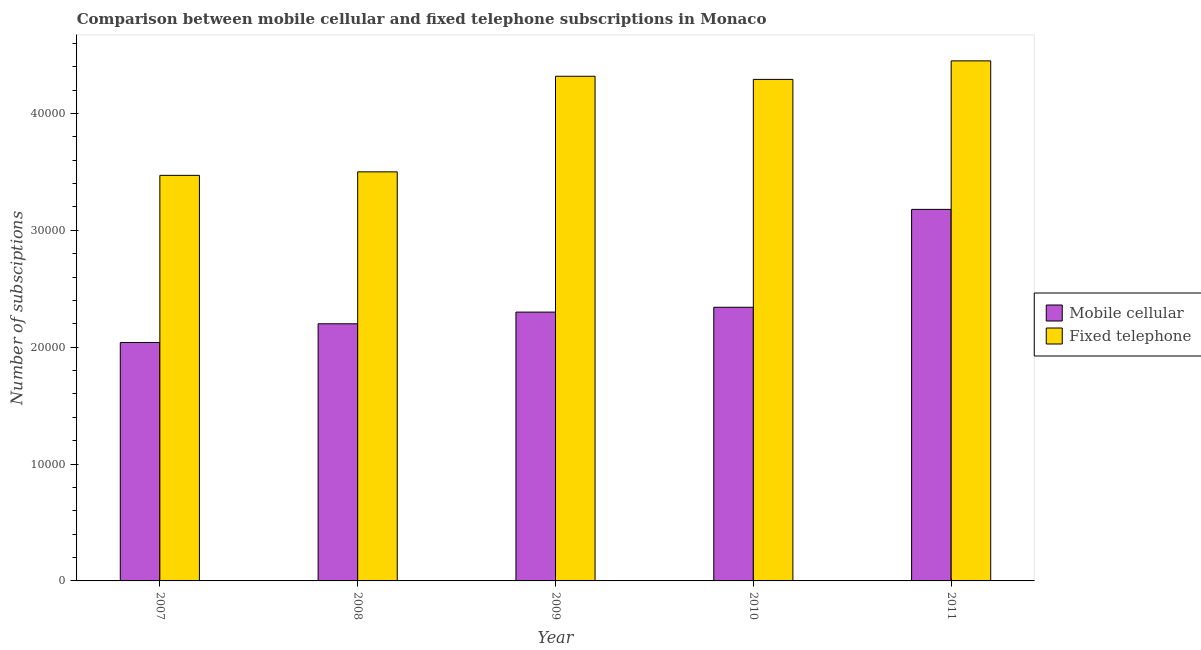How many groups of bars are there?
Provide a succinct answer. 5. Are the number of bars per tick equal to the number of legend labels?
Make the answer very short. Yes. How many bars are there on the 1st tick from the right?
Offer a very short reply. 2. What is the label of the 3rd group of bars from the left?
Offer a terse response. 2009. What is the number of mobile cellular subscriptions in 2011?
Your answer should be very brief. 3.18e+04. Across all years, what is the maximum number of mobile cellular subscriptions?
Give a very brief answer. 3.18e+04. Across all years, what is the minimum number of fixed telephone subscriptions?
Ensure brevity in your answer.  3.47e+04. In which year was the number of mobile cellular subscriptions maximum?
Offer a very short reply. 2011. In which year was the number of fixed telephone subscriptions minimum?
Keep it short and to the point. 2007. What is the total number of fixed telephone subscriptions in the graph?
Provide a short and direct response. 2.00e+05. What is the difference between the number of fixed telephone subscriptions in 2008 and that in 2011?
Your response must be concise. -9495. What is the difference between the number of fixed telephone subscriptions in 2011 and the number of mobile cellular subscriptions in 2010?
Your answer should be compact. 1585. What is the average number of mobile cellular subscriptions per year?
Your answer should be very brief. 2.41e+04. What is the ratio of the number of mobile cellular subscriptions in 2008 to that in 2011?
Your response must be concise. 0.69. Is the number of fixed telephone subscriptions in 2008 less than that in 2010?
Offer a very short reply. Yes. Is the difference between the number of mobile cellular subscriptions in 2008 and 2011 greater than the difference between the number of fixed telephone subscriptions in 2008 and 2011?
Your answer should be very brief. No. What is the difference between the highest and the second highest number of fixed telephone subscriptions?
Ensure brevity in your answer.  1316. What is the difference between the highest and the lowest number of fixed telephone subscriptions?
Your response must be concise. 9795. In how many years, is the number of fixed telephone subscriptions greater than the average number of fixed telephone subscriptions taken over all years?
Your answer should be compact. 3. Is the sum of the number of fixed telephone subscriptions in 2007 and 2008 greater than the maximum number of mobile cellular subscriptions across all years?
Provide a short and direct response. Yes. What does the 1st bar from the left in 2007 represents?
Your answer should be very brief. Mobile cellular. What does the 2nd bar from the right in 2009 represents?
Offer a very short reply. Mobile cellular. Are all the bars in the graph horizontal?
Give a very brief answer. No. How many years are there in the graph?
Your answer should be very brief. 5. Are the values on the major ticks of Y-axis written in scientific E-notation?
Make the answer very short. No. Does the graph contain any zero values?
Your answer should be very brief. No. Where does the legend appear in the graph?
Provide a succinct answer. Center right. How many legend labels are there?
Offer a very short reply. 2. How are the legend labels stacked?
Provide a succinct answer. Vertical. What is the title of the graph?
Ensure brevity in your answer.  Comparison between mobile cellular and fixed telephone subscriptions in Monaco. Does "Unregistered firms" appear as one of the legend labels in the graph?
Offer a terse response. No. What is the label or title of the X-axis?
Your answer should be very brief. Year. What is the label or title of the Y-axis?
Keep it short and to the point. Number of subsciptions. What is the Number of subsciptions of Mobile cellular in 2007?
Provide a short and direct response. 2.04e+04. What is the Number of subsciptions of Fixed telephone in 2007?
Provide a short and direct response. 3.47e+04. What is the Number of subsciptions in Mobile cellular in 2008?
Provide a succinct answer. 2.20e+04. What is the Number of subsciptions in Fixed telephone in 2008?
Make the answer very short. 3.50e+04. What is the Number of subsciptions of Mobile cellular in 2009?
Keep it short and to the point. 2.30e+04. What is the Number of subsciptions in Fixed telephone in 2009?
Offer a very short reply. 4.32e+04. What is the Number of subsciptions in Mobile cellular in 2010?
Your response must be concise. 2.34e+04. What is the Number of subsciptions of Fixed telephone in 2010?
Your answer should be compact. 4.29e+04. What is the Number of subsciptions in Mobile cellular in 2011?
Provide a short and direct response. 3.18e+04. What is the Number of subsciptions of Fixed telephone in 2011?
Provide a short and direct response. 4.45e+04. Across all years, what is the maximum Number of subsciptions in Mobile cellular?
Your answer should be very brief. 3.18e+04. Across all years, what is the maximum Number of subsciptions in Fixed telephone?
Your answer should be very brief. 4.45e+04. Across all years, what is the minimum Number of subsciptions of Mobile cellular?
Make the answer very short. 2.04e+04. Across all years, what is the minimum Number of subsciptions of Fixed telephone?
Your answer should be very brief. 3.47e+04. What is the total Number of subsciptions in Mobile cellular in the graph?
Keep it short and to the point. 1.21e+05. What is the total Number of subsciptions of Fixed telephone in the graph?
Your answer should be compact. 2.00e+05. What is the difference between the Number of subsciptions in Mobile cellular in 2007 and that in 2008?
Provide a succinct answer. -1600. What is the difference between the Number of subsciptions in Fixed telephone in 2007 and that in 2008?
Give a very brief answer. -300. What is the difference between the Number of subsciptions of Mobile cellular in 2007 and that in 2009?
Your answer should be compact. -2600. What is the difference between the Number of subsciptions in Fixed telephone in 2007 and that in 2009?
Provide a succinct answer. -8479. What is the difference between the Number of subsciptions of Mobile cellular in 2007 and that in 2010?
Make the answer very short. -3014. What is the difference between the Number of subsciptions of Fixed telephone in 2007 and that in 2010?
Keep it short and to the point. -8210. What is the difference between the Number of subsciptions of Mobile cellular in 2007 and that in 2011?
Offer a terse response. -1.14e+04. What is the difference between the Number of subsciptions of Fixed telephone in 2007 and that in 2011?
Provide a short and direct response. -9795. What is the difference between the Number of subsciptions of Mobile cellular in 2008 and that in 2009?
Provide a short and direct response. -1000. What is the difference between the Number of subsciptions of Fixed telephone in 2008 and that in 2009?
Keep it short and to the point. -8179. What is the difference between the Number of subsciptions in Mobile cellular in 2008 and that in 2010?
Provide a short and direct response. -1414. What is the difference between the Number of subsciptions in Fixed telephone in 2008 and that in 2010?
Your answer should be compact. -7910. What is the difference between the Number of subsciptions in Mobile cellular in 2008 and that in 2011?
Offer a terse response. -9789. What is the difference between the Number of subsciptions in Fixed telephone in 2008 and that in 2011?
Offer a very short reply. -9495. What is the difference between the Number of subsciptions in Mobile cellular in 2009 and that in 2010?
Provide a short and direct response. -414. What is the difference between the Number of subsciptions in Fixed telephone in 2009 and that in 2010?
Your answer should be compact. 269. What is the difference between the Number of subsciptions of Mobile cellular in 2009 and that in 2011?
Keep it short and to the point. -8789. What is the difference between the Number of subsciptions of Fixed telephone in 2009 and that in 2011?
Keep it short and to the point. -1316. What is the difference between the Number of subsciptions of Mobile cellular in 2010 and that in 2011?
Provide a succinct answer. -8375. What is the difference between the Number of subsciptions in Fixed telephone in 2010 and that in 2011?
Ensure brevity in your answer.  -1585. What is the difference between the Number of subsciptions in Mobile cellular in 2007 and the Number of subsciptions in Fixed telephone in 2008?
Make the answer very short. -1.46e+04. What is the difference between the Number of subsciptions of Mobile cellular in 2007 and the Number of subsciptions of Fixed telephone in 2009?
Offer a terse response. -2.28e+04. What is the difference between the Number of subsciptions of Mobile cellular in 2007 and the Number of subsciptions of Fixed telephone in 2010?
Offer a very short reply. -2.25e+04. What is the difference between the Number of subsciptions of Mobile cellular in 2007 and the Number of subsciptions of Fixed telephone in 2011?
Ensure brevity in your answer.  -2.41e+04. What is the difference between the Number of subsciptions of Mobile cellular in 2008 and the Number of subsciptions of Fixed telephone in 2009?
Offer a terse response. -2.12e+04. What is the difference between the Number of subsciptions in Mobile cellular in 2008 and the Number of subsciptions in Fixed telephone in 2010?
Keep it short and to the point. -2.09e+04. What is the difference between the Number of subsciptions in Mobile cellular in 2008 and the Number of subsciptions in Fixed telephone in 2011?
Offer a terse response. -2.25e+04. What is the difference between the Number of subsciptions of Mobile cellular in 2009 and the Number of subsciptions of Fixed telephone in 2010?
Provide a succinct answer. -1.99e+04. What is the difference between the Number of subsciptions of Mobile cellular in 2009 and the Number of subsciptions of Fixed telephone in 2011?
Offer a terse response. -2.15e+04. What is the difference between the Number of subsciptions of Mobile cellular in 2010 and the Number of subsciptions of Fixed telephone in 2011?
Ensure brevity in your answer.  -2.11e+04. What is the average Number of subsciptions in Mobile cellular per year?
Provide a short and direct response. 2.41e+04. What is the average Number of subsciptions in Fixed telephone per year?
Offer a very short reply. 4.01e+04. In the year 2007, what is the difference between the Number of subsciptions in Mobile cellular and Number of subsciptions in Fixed telephone?
Provide a succinct answer. -1.43e+04. In the year 2008, what is the difference between the Number of subsciptions of Mobile cellular and Number of subsciptions of Fixed telephone?
Your answer should be very brief. -1.30e+04. In the year 2009, what is the difference between the Number of subsciptions of Mobile cellular and Number of subsciptions of Fixed telephone?
Provide a succinct answer. -2.02e+04. In the year 2010, what is the difference between the Number of subsciptions of Mobile cellular and Number of subsciptions of Fixed telephone?
Your response must be concise. -1.95e+04. In the year 2011, what is the difference between the Number of subsciptions in Mobile cellular and Number of subsciptions in Fixed telephone?
Your answer should be compact. -1.27e+04. What is the ratio of the Number of subsciptions of Mobile cellular in 2007 to that in 2008?
Give a very brief answer. 0.93. What is the ratio of the Number of subsciptions of Fixed telephone in 2007 to that in 2008?
Ensure brevity in your answer.  0.99. What is the ratio of the Number of subsciptions of Mobile cellular in 2007 to that in 2009?
Ensure brevity in your answer.  0.89. What is the ratio of the Number of subsciptions in Fixed telephone in 2007 to that in 2009?
Your response must be concise. 0.8. What is the ratio of the Number of subsciptions of Mobile cellular in 2007 to that in 2010?
Provide a short and direct response. 0.87. What is the ratio of the Number of subsciptions of Fixed telephone in 2007 to that in 2010?
Provide a short and direct response. 0.81. What is the ratio of the Number of subsciptions of Mobile cellular in 2007 to that in 2011?
Provide a short and direct response. 0.64. What is the ratio of the Number of subsciptions in Fixed telephone in 2007 to that in 2011?
Give a very brief answer. 0.78. What is the ratio of the Number of subsciptions of Mobile cellular in 2008 to that in 2009?
Ensure brevity in your answer.  0.96. What is the ratio of the Number of subsciptions of Fixed telephone in 2008 to that in 2009?
Ensure brevity in your answer.  0.81. What is the ratio of the Number of subsciptions of Mobile cellular in 2008 to that in 2010?
Your answer should be compact. 0.94. What is the ratio of the Number of subsciptions of Fixed telephone in 2008 to that in 2010?
Your answer should be very brief. 0.82. What is the ratio of the Number of subsciptions of Mobile cellular in 2008 to that in 2011?
Make the answer very short. 0.69. What is the ratio of the Number of subsciptions of Fixed telephone in 2008 to that in 2011?
Make the answer very short. 0.79. What is the ratio of the Number of subsciptions in Mobile cellular in 2009 to that in 2010?
Your answer should be very brief. 0.98. What is the ratio of the Number of subsciptions of Fixed telephone in 2009 to that in 2010?
Provide a short and direct response. 1.01. What is the ratio of the Number of subsciptions in Mobile cellular in 2009 to that in 2011?
Make the answer very short. 0.72. What is the ratio of the Number of subsciptions in Fixed telephone in 2009 to that in 2011?
Keep it short and to the point. 0.97. What is the ratio of the Number of subsciptions in Mobile cellular in 2010 to that in 2011?
Provide a short and direct response. 0.74. What is the ratio of the Number of subsciptions in Fixed telephone in 2010 to that in 2011?
Offer a very short reply. 0.96. What is the difference between the highest and the second highest Number of subsciptions in Mobile cellular?
Provide a short and direct response. 8375. What is the difference between the highest and the second highest Number of subsciptions of Fixed telephone?
Provide a short and direct response. 1316. What is the difference between the highest and the lowest Number of subsciptions of Mobile cellular?
Your response must be concise. 1.14e+04. What is the difference between the highest and the lowest Number of subsciptions in Fixed telephone?
Ensure brevity in your answer.  9795. 